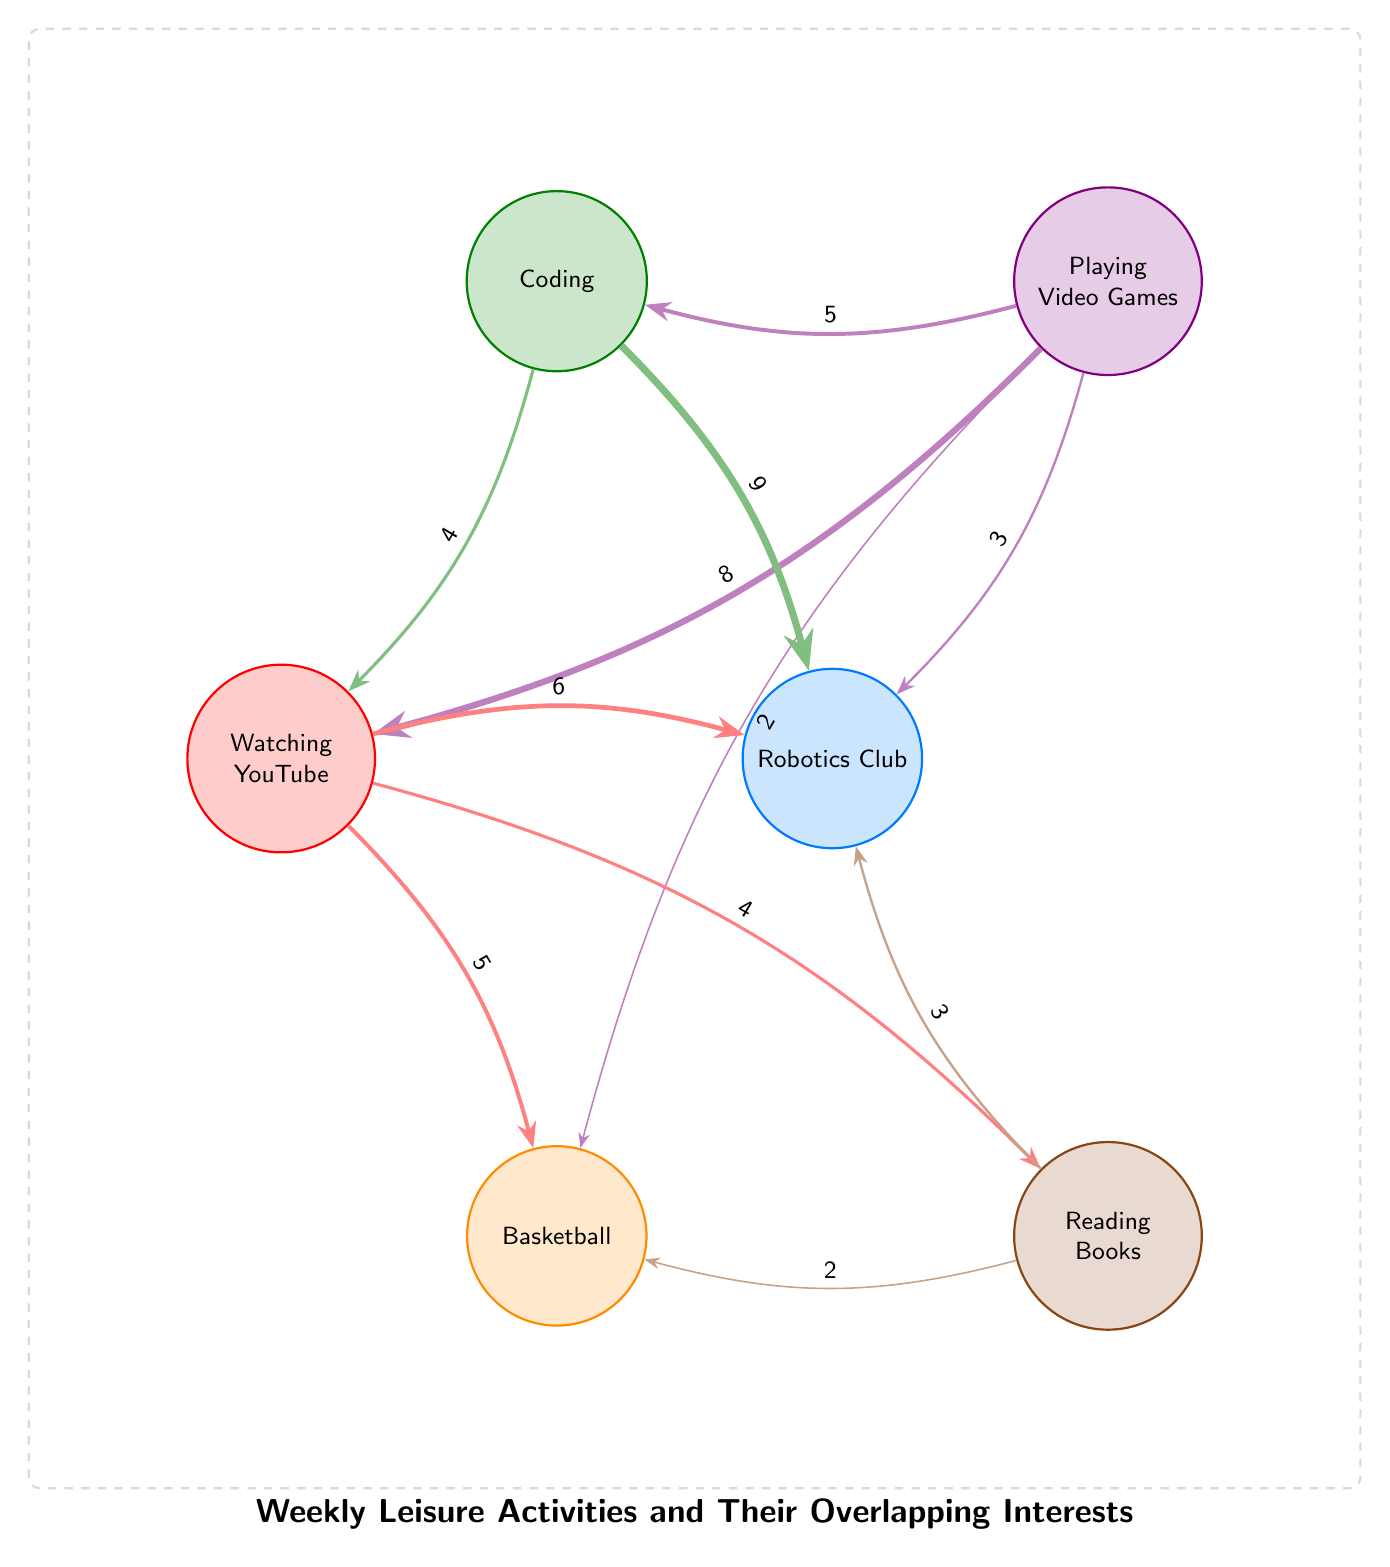What are the nodes present in the diagram? The nodes listed in the data represent different leisure activities. Specifically, they are: Playing Video Games, Coding, Watching YouTube, Robotics Club, Basketball, and Reading Books.
Answer: Playing Video Games, Coding, Watching YouTube, Robotics Club, Basketball, Reading Books How many links are shown in the diagram? The data details the connections (or links) between the nodes. Counting them gives a total of 10 links.
Answer: 10 What is the value of the link between Coding and Robotics Club? Referring to the data provided, the link between Coding and Robotics Club has a value of 9, indicating a strong overlap in interests.
Answer: 9 Which leisure activity has the highest connection to Watching YouTube? The connections show that Playing Video Games has the highest value link to Watching YouTube, valued at 8.
Answer: Playing Video Games How many activities are connected to the Robotics Club? Looking at the entries, Robotics Club is linked to Playing Video Games (3), Coding (9), Watching YouTube (6), and Reading Books (3), yielding a total of 4 connected activities.
Answer: 4 Which two activities have the strongest connection according to the values? Upon inspecting the links, the strongest connection is between Coding and Robotics Club with a value of 9.
Answer: Coding and Robotics Club What is the value of the connection between Basketball and Watching YouTube? The value of the link connecting Basketball and Watching YouTube is provided as 5 in the data.
Answer: 5 Which two activities share the least connection value? Among all the connections, the link between Playing Video Games and Basketball has the lowest value of 2, indicating a minimal overlap in interests.
Answer: Playing Video Games and Basketball How many total overlaps involve Reading Books? Reading Books has links with Basketball (2), Watching YouTube (4), and Robotics Club (3), resulting in a total of 3 overlaps.
Answer: 3 